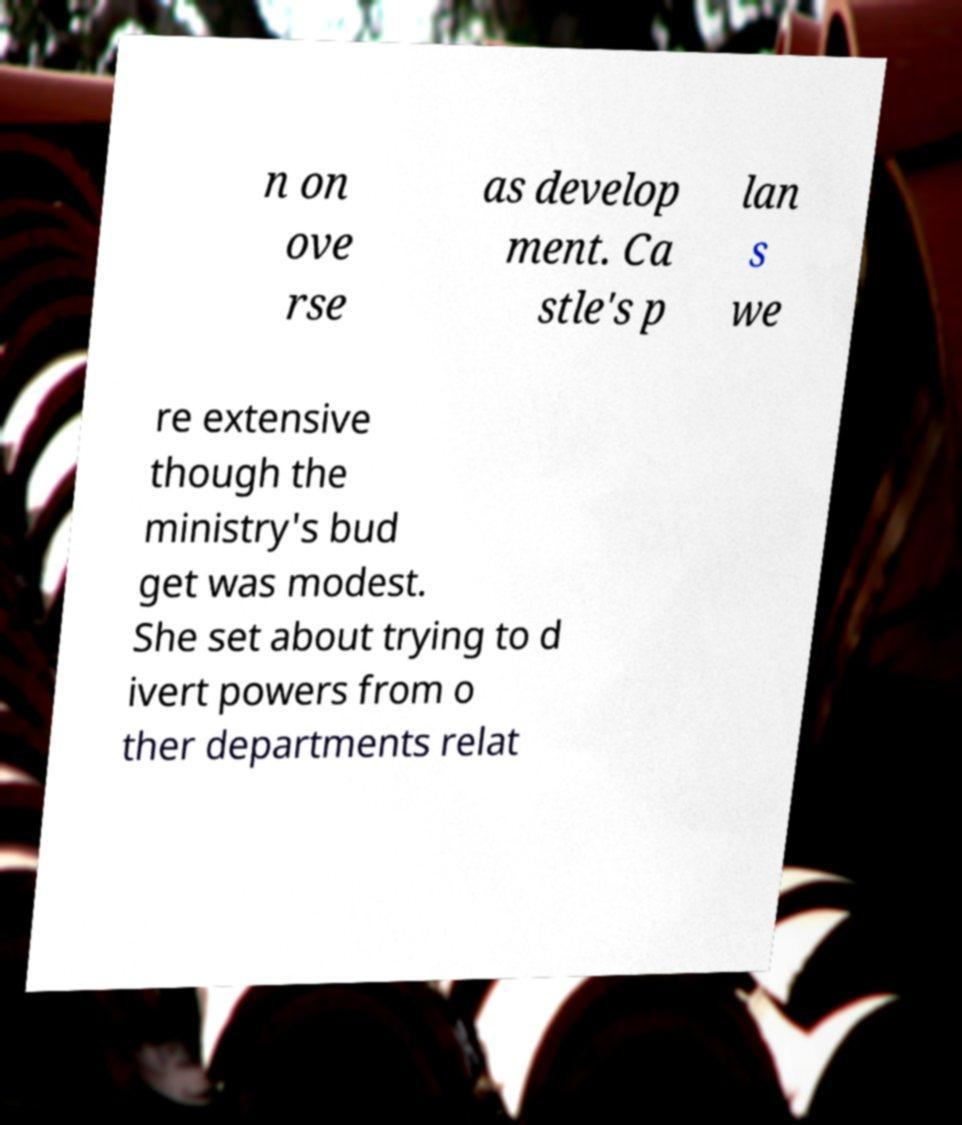Can you accurately transcribe the text from the provided image for me? n on ove rse as develop ment. Ca stle's p lan s we re extensive though the ministry's bud get was modest. She set about trying to d ivert powers from o ther departments relat 